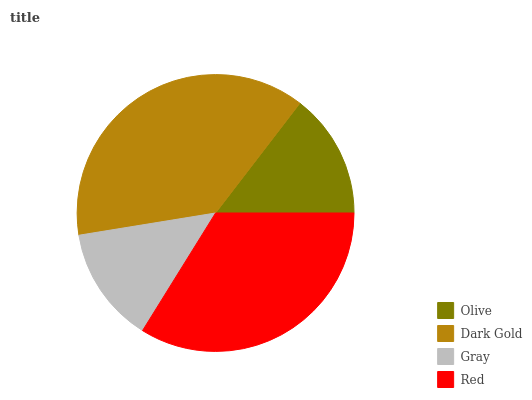Is Gray the minimum?
Answer yes or no. Yes. Is Dark Gold the maximum?
Answer yes or no. Yes. Is Dark Gold the minimum?
Answer yes or no. No. Is Gray the maximum?
Answer yes or no. No. Is Dark Gold greater than Gray?
Answer yes or no. Yes. Is Gray less than Dark Gold?
Answer yes or no. Yes. Is Gray greater than Dark Gold?
Answer yes or no. No. Is Dark Gold less than Gray?
Answer yes or no. No. Is Red the high median?
Answer yes or no. Yes. Is Olive the low median?
Answer yes or no. Yes. Is Gray the high median?
Answer yes or no. No. Is Red the low median?
Answer yes or no. No. 